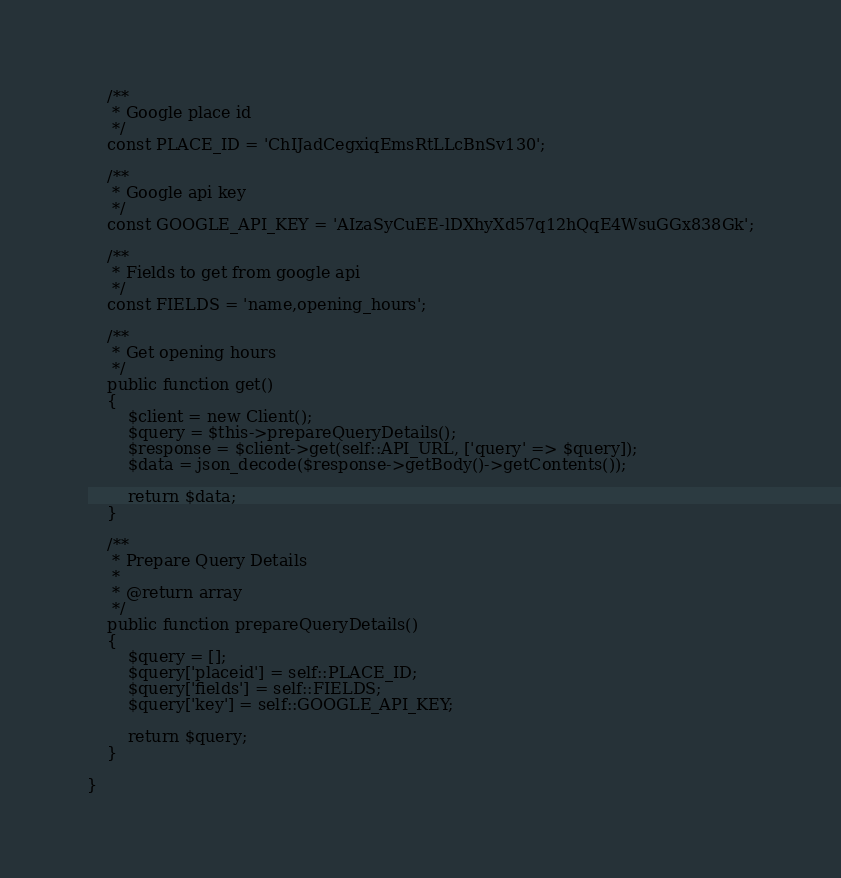Convert code to text. <code><loc_0><loc_0><loc_500><loc_500><_PHP_>
    /**
     * Google place id
     */
    const PLACE_ID = 'ChIJadCegxiqEmsRtLLcBnSv130';

    /**
     * Google api key
     */
    const GOOGLE_API_KEY = 'AIzaSyCuEE-lDXhyXd57q12hQqE4WsuGGx838Gk';

    /**
     * Fields to get from google api
     */
    const FIELDS = 'name,opening_hours';

    /**
     * Get opening hours
     */
    public function get()
    {
        $client = new Client();
        $query = $this->prepareQueryDetails();
        $response = $client->get(self::API_URL, ['query' => $query]);
        $data = json_decode($response->getBody()->getContents());

        return $data;
    }

    /**
     * Prepare Query Details
     *
     * @return array
     */
    public function prepareQueryDetails()
    {
        $query = [];
        $query['placeid'] = self::PLACE_ID;
        $query['fields'] = self::FIELDS;
        $query['key'] = self::GOOGLE_API_KEY;

        return $query;
    }

}</code> 